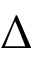<formula> <loc_0><loc_0><loc_500><loc_500>\Delta</formula> 